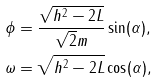<formula> <loc_0><loc_0><loc_500><loc_500>\phi & = \frac { \sqrt { h ^ { 2 } - 2 L } } { \sqrt { 2 } m } \sin ( \alpha ) , \\ \omega & = \sqrt { h ^ { 2 } - 2 L } \cos ( \alpha ) ,</formula> 